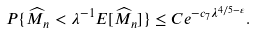Convert formula to latex. <formula><loc_0><loc_0><loc_500><loc_500>P \{ \widehat { M } _ { n } < \lambda ^ { - 1 } E [ \widehat { M } _ { n } ] \} \leq C e ^ { - c _ { 7 } \lambda ^ { 4 / 5 - \varepsilon } } .</formula> 